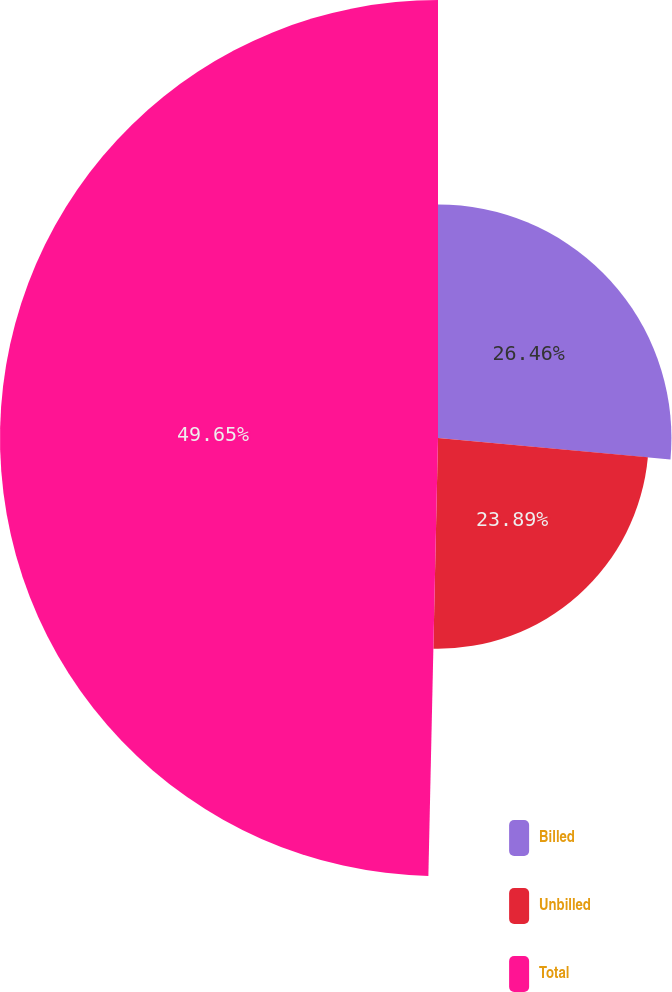Convert chart. <chart><loc_0><loc_0><loc_500><loc_500><pie_chart><fcel>Billed<fcel>Unbilled<fcel>Total<nl><fcel>26.46%<fcel>23.89%<fcel>49.65%<nl></chart> 